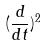Convert formula to latex. <formula><loc_0><loc_0><loc_500><loc_500>( \frac { d } { d t } ) ^ { 2 }</formula> 